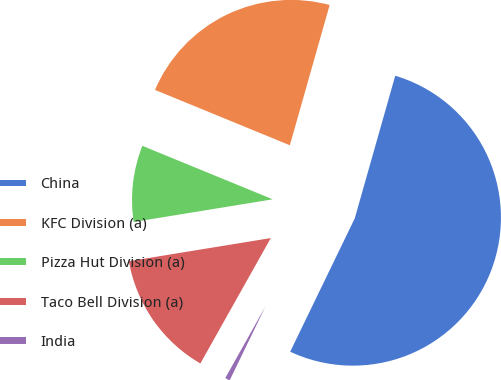Convert chart to OTSL. <chart><loc_0><loc_0><loc_500><loc_500><pie_chart><fcel>China<fcel>KFC Division (a)<fcel>Pizza Hut Division (a)<fcel>Taco Bell Division (a)<fcel>India<nl><fcel>52.77%<fcel>23.2%<fcel>8.77%<fcel>14.28%<fcel>0.97%<nl></chart> 